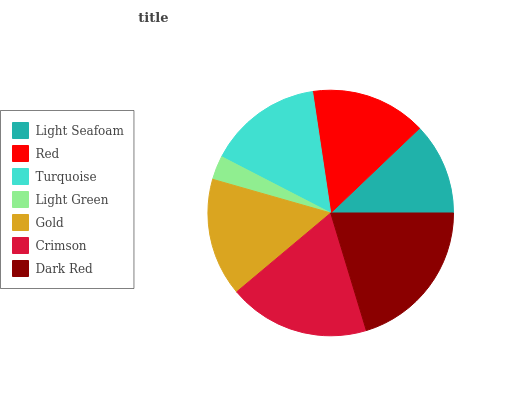Is Light Green the minimum?
Answer yes or no. Yes. Is Dark Red the maximum?
Answer yes or no. Yes. Is Red the minimum?
Answer yes or no. No. Is Red the maximum?
Answer yes or no. No. Is Red greater than Light Seafoam?
Answer yes or no. Yes. Is Light Seafoam less than Red?
Answer yes or no. Yes. Is Light Seafoam greater than Red?
Answer yes or no. No. Is Red less than Light Seafoam?
Answer yes or no. No. Is Red the high median?
Answer yes or no. Yes. Is Red the low median?
Answer yes or no. Yes. Is Gold the high median?
Answer yes or no. No. Is Light Green the low median?
Answer yes or no. No. 